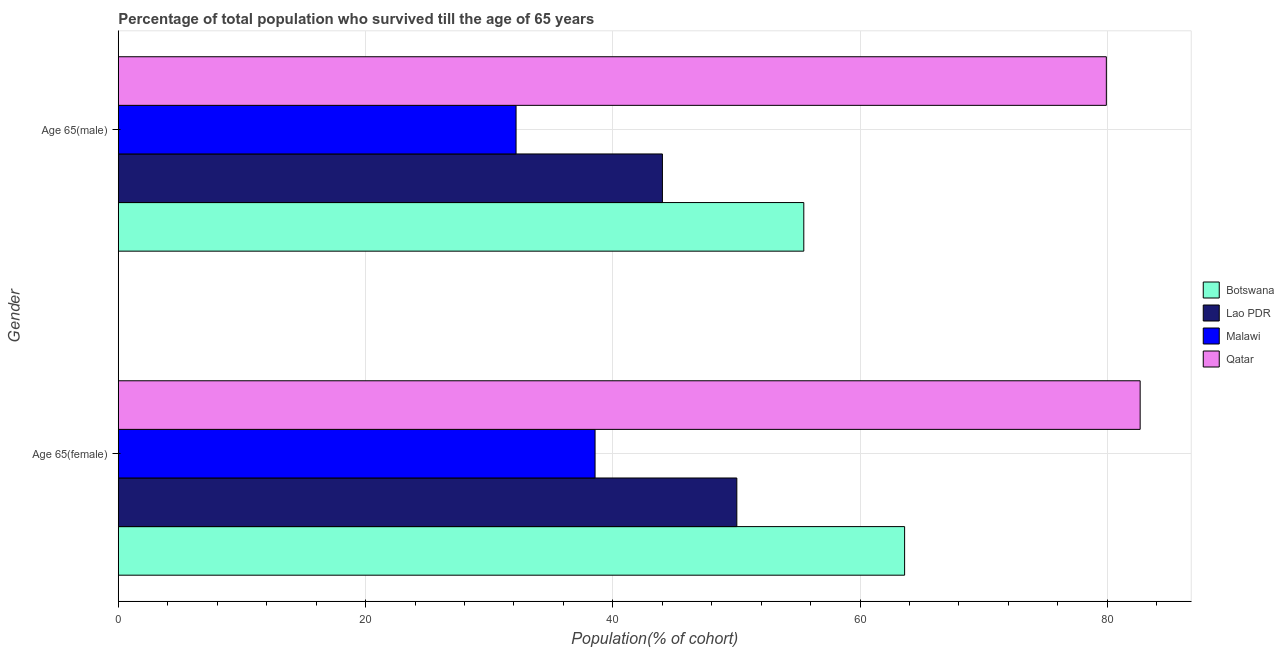Are the number of bars on each tick of the Y-axis equal?
Your response must be concise. Yes. How many bars are there on the 2nd tick from the top?
Ensure brevity in your answer.  4. What is the label of the 1st group of bars from the top?
Keep it short and to the point. Age 65(male). What is the percentage of female population who survived till age of 65 in Lao PDR?
Provide a short and direct response. 50.03. Across all countries, what is the maximum percentage of male population who survived till age of 65?
Provide a succinct answer. 79.92. Across all countries, what is the minimum percentage of female population who survived till age of 65?
Your response must be concise. 38.56. In which country was the percentage of male population who survived till age of 65 maximum?
Your response must be concise. Qatar. In which country was the percentage of male population who survived till age of 65 minimum?
Your answer should be very brief. Malawi. What is the total percentage of male population who survived till age of 65 in the graph?
Offer a very short reply. 211.56. What is the difference between the percentage of male population who survived till age of 65 in Lao PDR and that in Malawi?
Your answer should be compact. 11.84. What is the difference between the percentage of male population who survived till age of 65 in Qatar and the percentage of female population who survived till age of 65 in Lao PDR?
Keep it short and to the point. 29.89. What is the average percentage of male population who survived till age of 65 per country?
Provide a succinct answer. 52.89. What is the difference between the percentage of male population who survived till age of 65 and percentage of female population who survived till age of 65 in Botswana?
Offer a terse response. -8.15. In how many countries, is the percentage of female population who survived till age of 65 greater than 44 %?
Your answer should be very brief. 3. What is the ratio of the percentage of male population who survived till age of 65 in Lao PDR to that in Botswana?
Your answer should be compact. 0.79. Is the percentage of male population who survived till age of 65 in Malawi less than that in Qatar?
Provide a succinct answer. Yes. What does the 2nd bar from the top in Age 65(male) represents?
Provide a short and direct response. Malawi. What does the 2nd bar from the bottom in Age 65(male) represents?
Offer a terse response. Lao PDR. How many bars are there?
Ensure brevity in your answer.  8. Are all the bars in the graph horizontal?
Offer a terse response. Yes. Does the graph contain any zero values?
Your response must be concise. No. Does the graph contain grids?
Your answer should be very brief. Yes. How many legend labels are there?
Provide a succinct answer. 4. What is the title of the graph?
Make the answer very short. Percentage of total population who survived till the age of 65 years. What is the label or title of the X-axis?
Keep it short and to the point. Population(% of cohort). What is the Population(% of cohort) of Botswana in Age 65(female)?
Give a very brief answer. 63.6. What is the Population(% of cohort) in Lao PDR in Age 65(female)?
Provide a succinct answer. 50.03. What is the Population(% of cohort) in Malawi in Age 65(female)?
Your answer should be compact. 38.56. What is the Population(% of cohort) of Qatar in Age 65(female)?
Your response must be concise. 82.65. What is the Population(% of cohort) in Botswana in Age 65(male)?
Give a very brief answer. 55.45. What is the Population(% of cohort) of Lao PDR in Age 65(male)?
Your response must be concise. 44.01. What is the Population(% of cohort) of Malawi in Age 65(male)?
Provide a short and direct response. 32.17. What is the Population(% of cohort) in Qatar in Age 65(male)?
Offer a very short reply. 79.92. Across all Gender, what is the maximum Population(% of cohort) in Botswana?
Provide a succinct answer. 63.6. Across all Gender, what is the maximum Population(% of cohort) of Lao PDR?
Make the answer very short. 50.03. Across all Gender, what is the maximum Population(% of cohort) of Malawi?
Offer a terse response. 38.56. Across all Gender, what is the maximum Population(% of cohort) in Qatar?
Your response must be concise. 82.65. Across all Gender, what is the minimum Population(% of cohort) of Botswana?
Keep it short and to the point. 55.45. Across all Gender, what is the minimum Population(% of cohort) of Lao PDR?
Ensure brevity in your answer.  44.01. Across all Gender, what is the minimum Population(% of cohort) in Malawi?
Provide a short and direct response. 32.17. Across all Gender, what is the minimum Population(% of cohort) of Qatar?
Ensure brevity in your answer.  79.92. What is the total Population(% of cohort) in Botswana in the graph?
Ensure brevity in your answer.  119.05. What is the total Population(% of cohort) in Lao PDR in the graph?
Your answer should be compact. 94.05. What is the total Population(% of cohort) in Malawi in the graph?
Your answer should be very brief. 70.74. What is the total Population(% of cohort) in Qatar in the graph?
Keep it short and to the point. 162.58. What is the difference between the Population(% of cohort) of Botswana in Age 65(female) and that in Age 65(male)?
Your response must be concise. 8.15. What is the difference between the Population(% of cohort) in Lao PDR in Age 65(female) and that in Age 65(male)?
Your answer should be very brief. 6.02. What is the difference between the Population(% of cohort) of Malawi in Age 65(female) and that in Age 65(male)?
Provide a succinct answer. 6.39. What is the difference between the Population(% of cohort) in Qatar in Age 65(female) and that in Age 65(male)?
Your answer should be very brief. 2.73. What is the difference between the Population(% of cohort) of Botswana in Age 65(female) and the Population(% of cohort) of Lao PDR in Age 65(male)?
Ensure brevity in your answer.  19.59. What is the difference between the Population(% of cohort) of Botswana in Age 65(female) and the Population(% of cohort) of Malawi in Age 65(male)?
Provide a succinct answer. 31.43. What is the difference between the Population(% of cohort) of Botswana in Age 65(female) and the Population(% of cohort) of Qatar in Age 65(male)?
Provide a succinct answer. -16.32. What is the difference between the Population(% of cohort) of Lao PDR in Age 65(female) and the Population(% of cohort) of Malawi in Age 65(male)?
Keep it short and to the point. 17.86. What is the difference between the Population(% of cohort) of Lao PDR in Age 65(female) and the Population(% of cohort) of Qatar in Age 65(male)?
Ensure brevity in your answer.  -29.89. What is the difference between the Population(% of cohort) of Malawi in Age 65(female) and the Population(% of cohort) of Qatar in Age 65(male)?
Your answer should be compact. -41.36. What is the average Population(% of cohort) in Botswana per Gender?
Give a very brief answer. 59.53. What is the average Population(% of cohort) of Lao PDR per Gender?
Make the answer very short. 47.02. What is the average Population(% of cohort) in Malawi per Gender?
Provide a short and direct response. 35.37. What is the average Population(% of cohort) of Qatar per Gender?
Ensure brevity in your answer.  81.29. What is the difference between the Population(% of cohort) in Botswana and Population(% of cohort) in Lao PDR in Age 65(female)?
Keep it short and to the point. 13.57. What is the difference between the Population(% of cohort) of Botswana and Population(% of cohort) of Malawi in Age 65(female)?
Make the answer very short. 25.04. What is the difference between the Population(% of cohort) of Botswana and Population(% of cohort) of Qatar in Age 65(female)?
Offer a very short reply. -19.05. What is the difference between the Population(% of cohort) in Lao PDR and Population(% of cohort) in Malawi in Age 65(female)?
Provide a succinct answer. 11.47. What is the difference between the Population(% of cohort) of Lao PDR and Population(% of cohort) of Qatar in Age 65(female)?
Offer a terse response. -32.62. What is the difference between the Population(% of cohort) in Malawi and Population(% of cohort) in Qatar in Age 65(female)?
Ensure brevity in your answer.  -44.09. What is the difference between the Population(% of cohort) in Botswana and Population(% of cohort) in Lao PDR in Age 65(male)?
Keep it short and to the point. 11.44. What is the difference between the Population(% of cohort) in Botswana and Population(% of cohort) in Malawi in Age 65(male)?
Your answer should be compact. 23.27. What is the difference between the Population(% of cohort) of Botswana and Population(% of cohort) of Qatar in Age 65(male)?
Provide a succinct answer. -24.47. What is the difference between the Population(% of cohort) in Lao PDR and Population(% of cohort) in Malawi in Age 65(male)?
Your response must be concise. 11.84. What is the difference between the Population(% of cohort) of Lao PDR and Population(% of cohort) of Qatar in Age 65(male)?
Give a very brief answer. -35.91. What is the difference between the Population(% of cohort) in Malawi and Population(% of cohort) in Qatar in Age 65(male)?
Offer a terse response. -47.75. What is the ratio of the Population(% of cohort) of Botswana in Age 65(female) to that in Age 65(male)?
Your answer should be compact. 1.15. What is the ratio of the Population(% of cohort) of Lao PDR in Age 65(female) to that in Age 65(male)?
Ensure brevity in your answer.  1.14. What is the ratio of the Population(% of cohort) in Malawi in Age 65(female) to that in Age 65(male)?
Make the answer very short. 1.2. What is the ratio of the Population(% of cohort) in Qatar in Age 65(female) to that in Age 65(male)?
Make the answer very short. 1.03. What is the difference between the highest and the second highest Population(% of cohort) of Botswana?
Ensure brevity in your answer.  8.15. What is the difference between the highest and the second highest Population(% of cohort) in Lao PDR?
Your answer should be very brief. 6.02. What is the difference between the highest and the second highest Population(% of cohort) in Malawi?
Your response must be concise. 6.39. What is the difference between the highest and the second highest Population(% of cohort) in Qatar?
Your response must be concise. 2.73. What is the difference between the highest and the lowest Population(% of cohort) of Botswana?
Make the answer very short. 8.15. What is the difference between the highest and the lowest Population(% of cohort) of Lao PDR?
Your answer should be very brief. 6.02. What is the difference between the highest and the lowest Population(% of cohort) in Malawi?
Your response must be concise. 6.39. What is the difference between the highest and the lowest Population(% of cohort) of Qatar?
Ensure brevity in your answer.  2.73. 